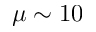<formula> <loc_0><loc_0><loc_500><loc_500>\mu \sim 1 0</formula> 